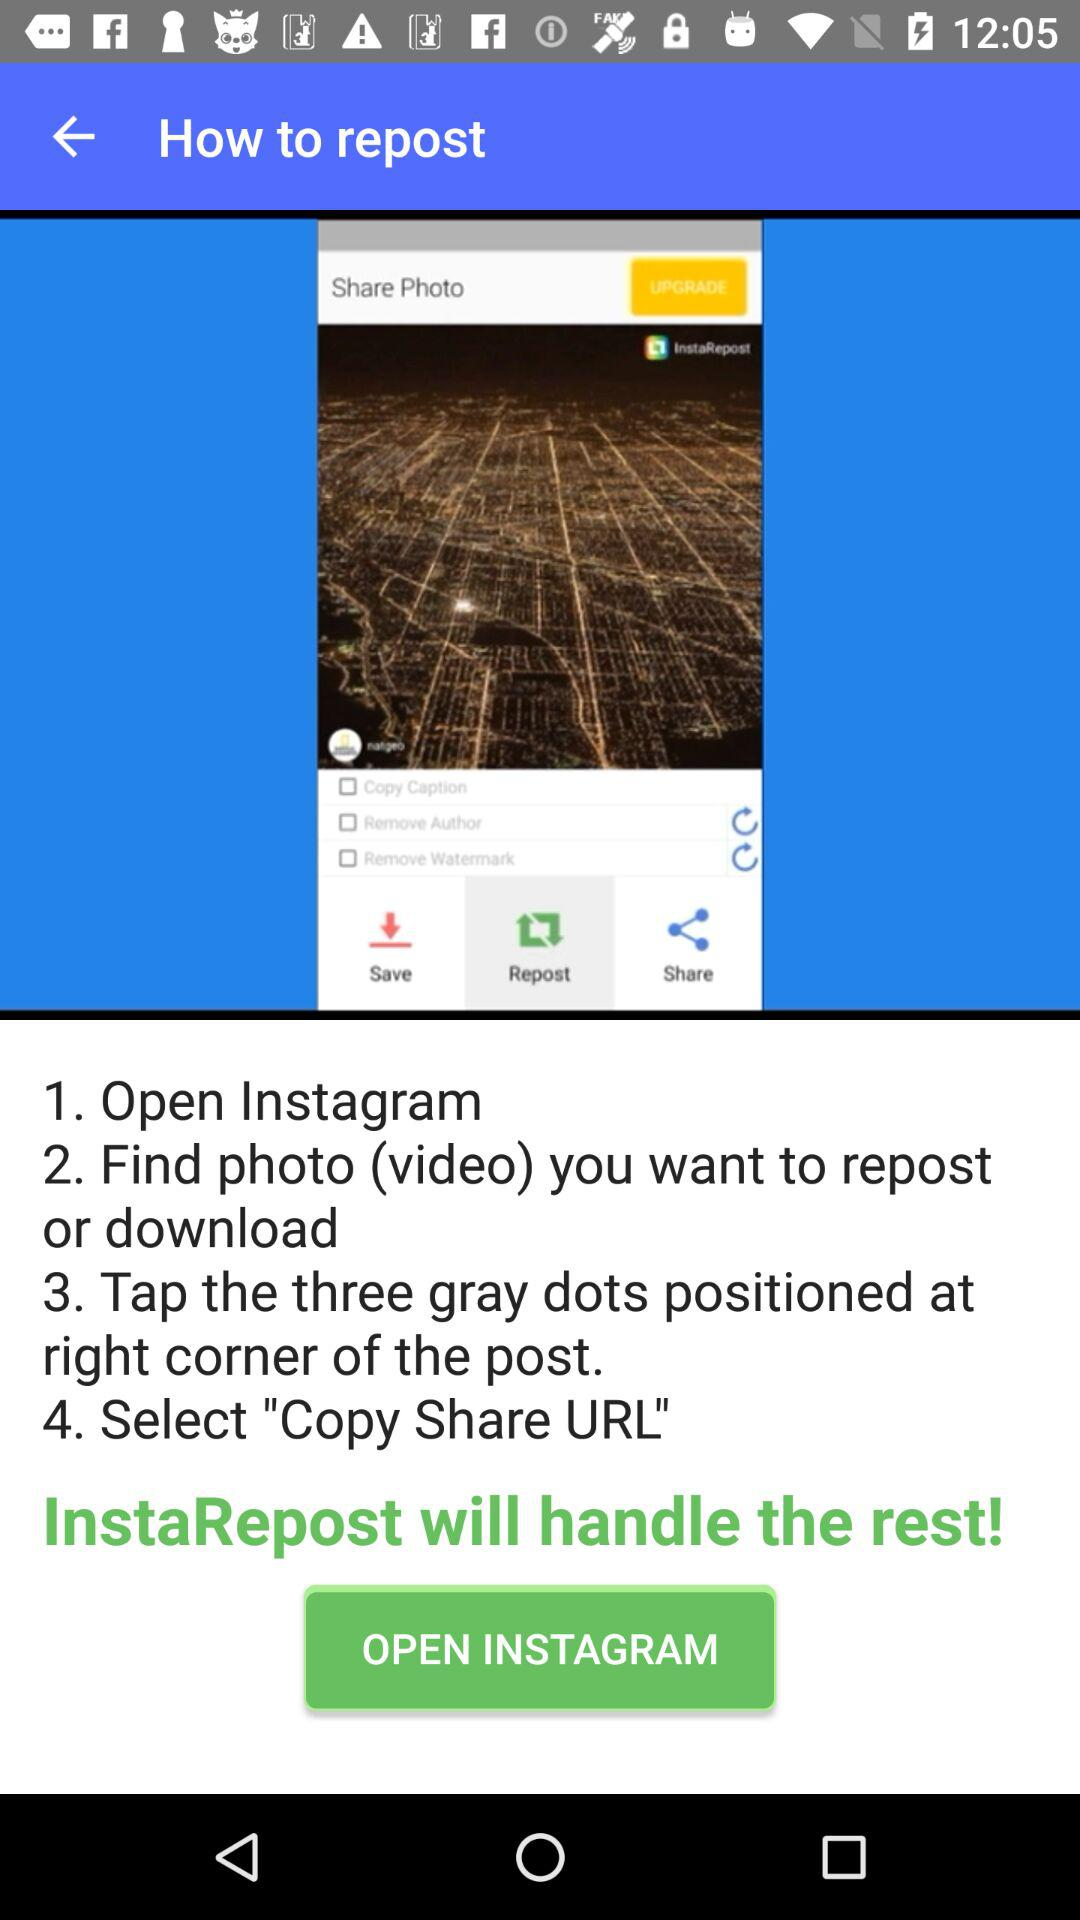How many steps are there in the instructions?
Answer the question using a single word or phrase. 4 